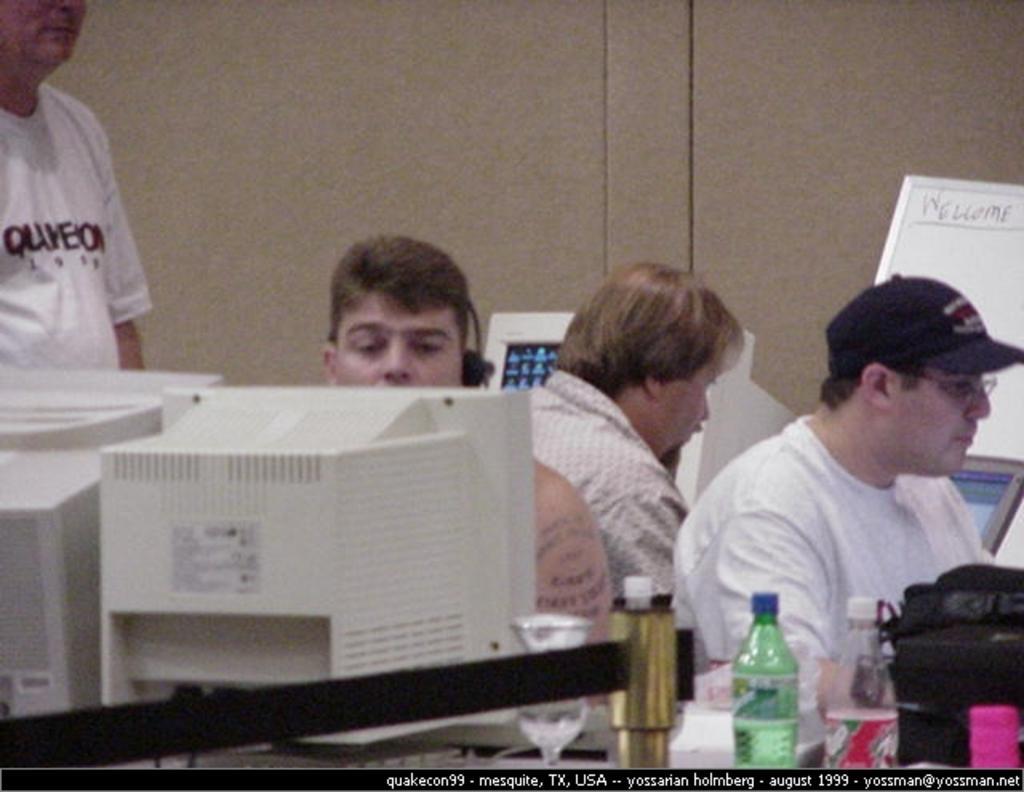Can you describe this image briefly? In this image there are group of persons. On left side man wearing a white shirt a standing. In the center man is sitting on a computer and is looking at the computer screen. At the right side the man wearing a black colour hat is doing some work. In the background the man is sitting in front of the computer. In the background there is a wall, white colour board with welcome written on it. In the front there is a black colour bag, 2 bottles. 